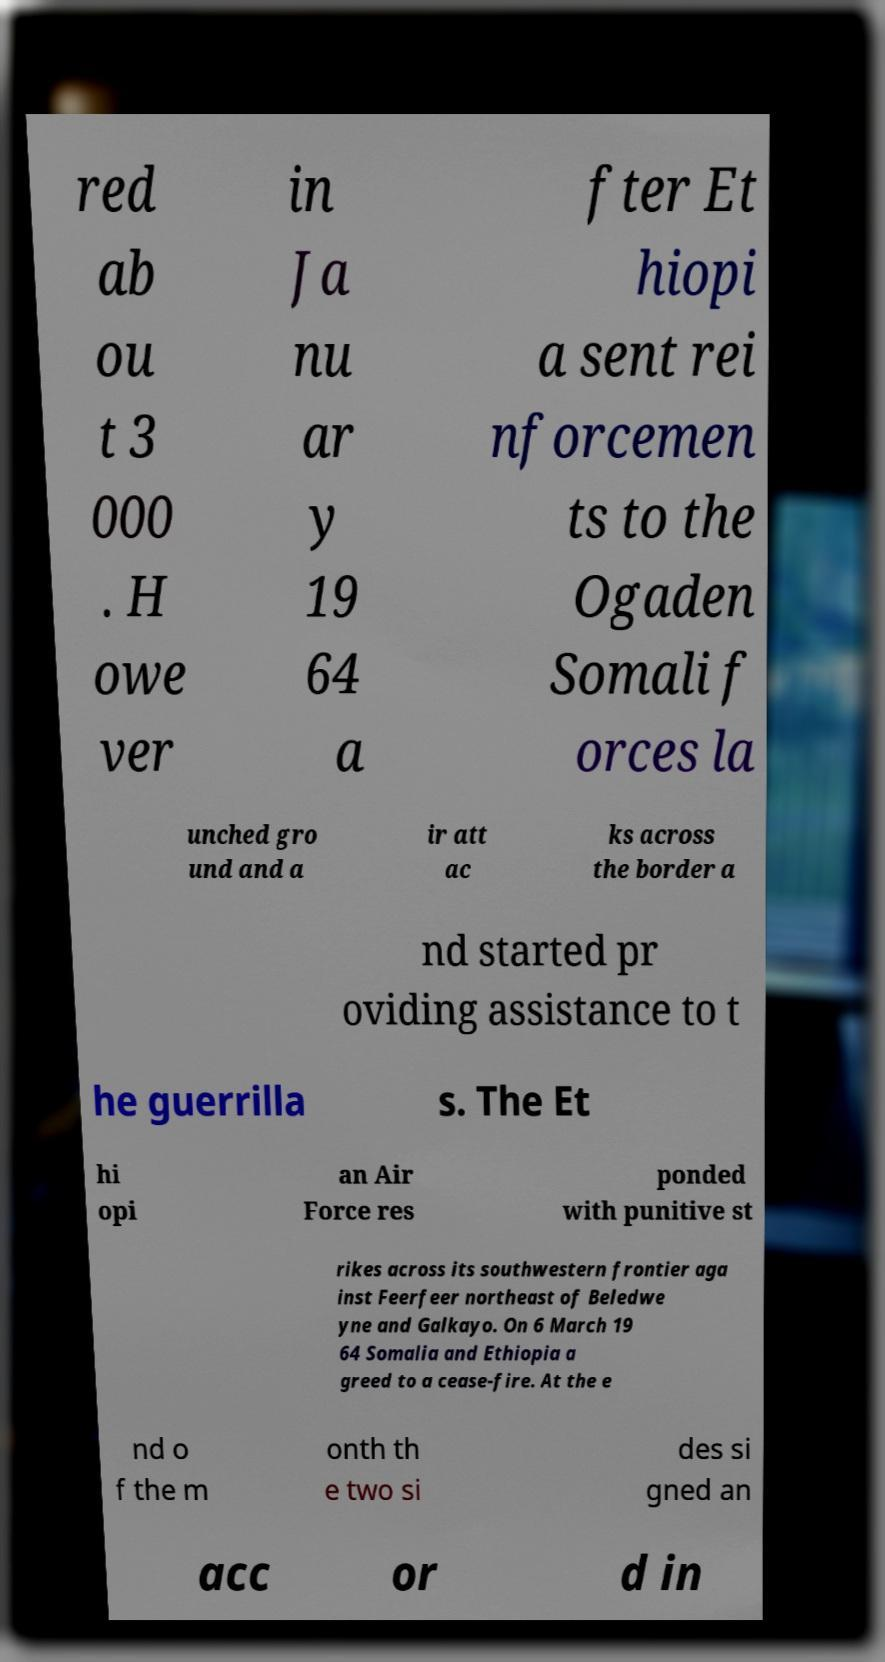Please read and relay the text visible in this image. What does it say? red ab ou t 3 000 . H owe ver in Ja nu ar y 19 64 a fter Et hiopi a sent rei nforcemen ts to the Ogaden Somali f orces la unched gro und and a ir att ac ks across the border a nd started pr oviding assistance to t he guerrilla s. The Et hi opi an Air Force res ponded with punitive st rikes across its southwestern frontier aga inst Feerfeer northeast of Beledwe yne and Galkayo. On 6 March 19 64 Somalia and Ethiopia a greed to a cease-fire. At the e nd o f the m onth th e two si des si gned an acc or d in 